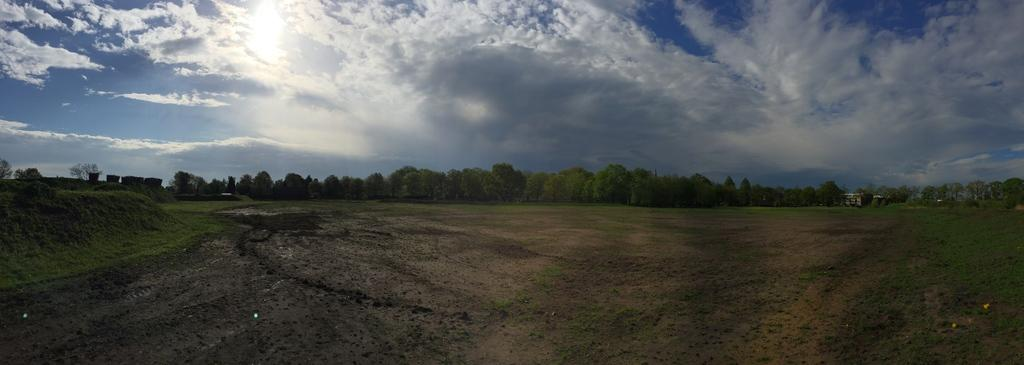What type of ground covering is visible in the image? The ground in the image is covered with grass. What can be seen in the distance in the image? There are many trees visible in the background. How would you describe the sky in the image? The sky in the image is cloudy. What shape is the chain that is hanging from the tree in the image? There is no chain hanging from a tree in the image; it only features grass, trees, and a cloudy sky. 